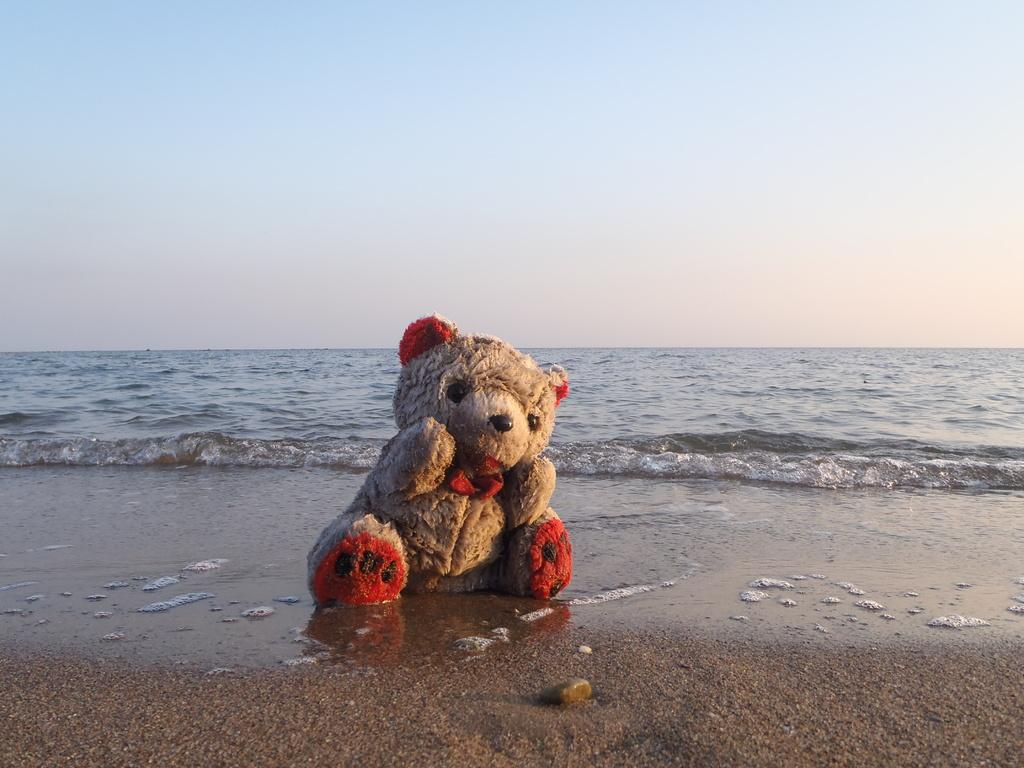What type of toy is present in the image? There is a teddy bear in the image. What colors are used for the teddy bear? The teddy bear is in cream and red colors. What can be seen in the background of the image? There is water visible in the background of the image. How would you describe the color of the sky in the image? The sky is blue and white in color. How many corks are floating in the water in the image? There are no corks visible in the image; only water is present in the background. What type of reward is the teddy bear holding in the image? There is no reward present in the image; the teddy bear is simply a toy. 